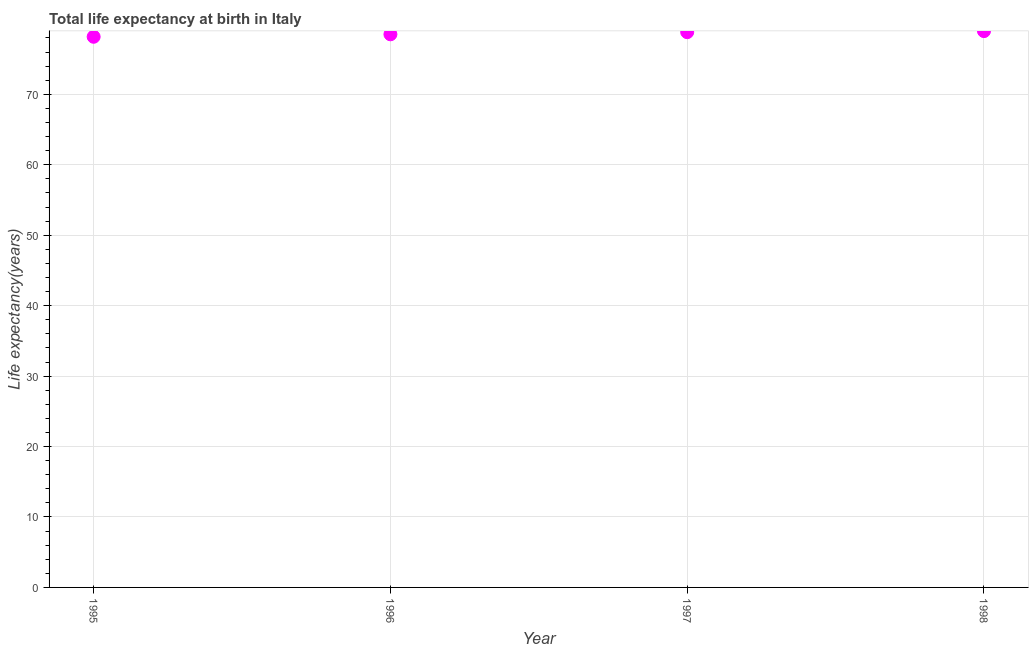What is the life expectancy at birth in 1996?
Keep it short and to the point. 78.52. Across all years, what is the maximum life expectancy at birth?
Your answer should be compact. 78.98. Across all years, what is the minimum life expectancy at birth?
Offer a very short reply. 78.17. In which year was the life expectancy at birth maximum?
Provide a short and direct response. 1998. What is the sum of the life expectancy at birth?
Keep it short and to the point. 314.49. What is the difference between the life expectancy at birth in 1996 and 1997?
Provide a short and direct response. -0.3. What is the average life expectancy at birth per year?
Provide a succinct answer. 78.62. What is the median life expectancy at birth?
Give a very brief answer. 78.67. What is the ratio of the life expectancy at birth in 1996 to that in 1997?
Ensure brevity in your answer.  1. What is the difference between the highest and the second highest life expectancy at birth?
Offer a very short reply. 0.15. What is the difference between the highest and the lowest life expectancy at birth?
Ensure brevity in your answer.  0.8. Does the life expectancy at birth monotonically increase over the years?
Keep it short and to the point. Yes. How many dotlines are there?
Ensure brevity in your answer.  1. What is the difference between two consecutive major ticks on the Y-axis?
Ensure brevity in your answer.  10. Are the values on the major ticks of Y-axis written in scientific E-notation?
Offer a terse response. No. Does the graph contain grids?
Your answer should be very brief. Yes. What is the title of the graph?
Give a very brief answer. Total life expectancy at birth in Italy. What is the label or title of the X-axis?
Offer a terse response. Year. What is the label or title of the Y-axis?
Provide a short and direct response. Life expectancy(years). What is the Life expectancy(years) in 1995?
Provide a succinct answer. 78.17. What is the Life expectancy(years) in 1996?
Provide a short and direct response. 78.52. What is the Life expectancy(years) in 1997?
Ensure brevity in your answer.  78.82. What is the Life expectancy(years) in 1998?
Offer a very short reply. 78.98. What is the difference between the Life expectancy(years) in 1995 and 1996?
Your answer should be very brief. -0.35. What is the difference between the Life expectancy(years) in 1995 and 1997?
Provide a short and direct response. -0.65. What is the difference between the Life expectancy(years) in 1995 and 1998?
Your answer should be very brief. -0.8. What is the difference between the Life expectancy(years) in 1996 and 1997?
Offer a terse response. -0.3. What is the difference between the Life expectancy(years) in 1996 and 1998?
Your response must be concise. -0.45. What is the difference between the Life expectancy(years) in 1997 and 1998?
Provide a succinct answer. -0.15. What is the ratio of the Life expectancy(years) in 1995 to that in 1996?
Keep it short and to the point. 1. What is the ratio of the Life expectancy(years) in 1996 to that in 1998?
Your answer should be compact. 0.99. What is the ratio of the Life expectancy(years) in 1997 to that in 1998?
Offer a very short reply. 1. 